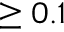Convert formula to latex. <formula><loc_0><loc_0><loc_500><loc_500>\geq 0 . 1</formula> 